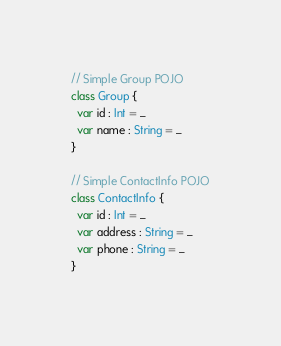<code> <loc_0><loc_0><loc_500><loc_500><_Scala_>
// Simple Group POJO
class Group {
  var id : Int = _
  var name : String = _
}

// Simple ContactInfo POJO
class ContactInfo {
  var id : Int = _
  var address : String = _
  var phone : String = _
}
</code> 